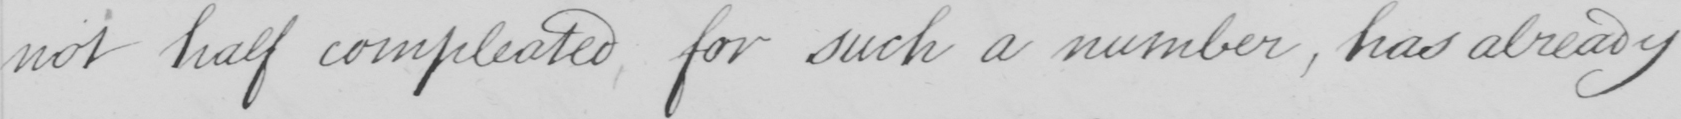What is written in this line of handwriting? not half compleated for such a number , has already 